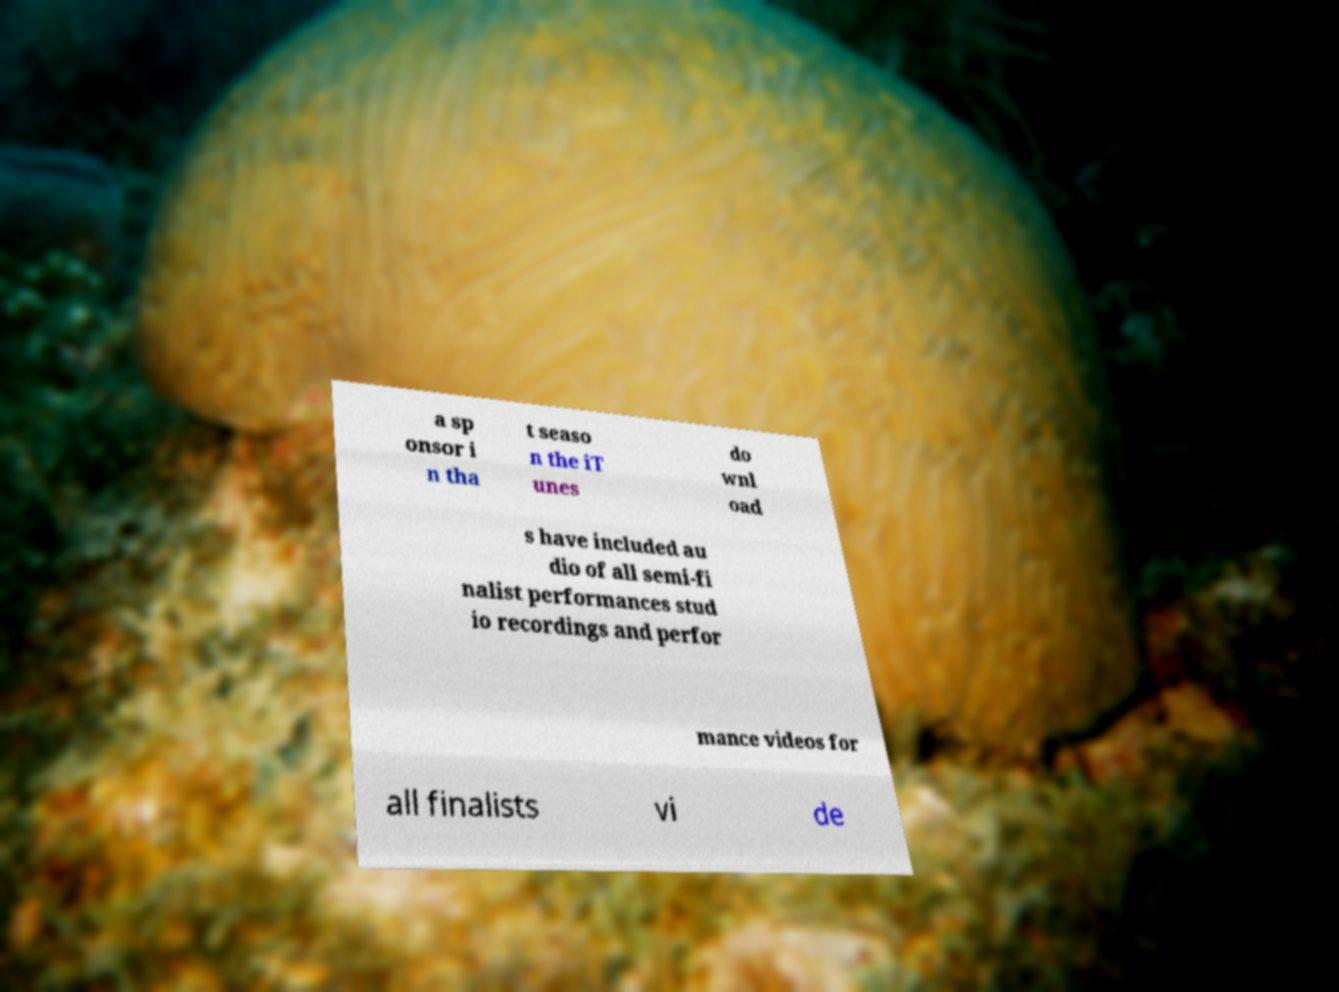Please identify and transcribe the text found in this image. a sp onsor i n tha t seaso n the iT unes do wnl oad s have included au dio of all semi-fi nalist performances stud io recordings and perfor mance videos for all finalists vi de 